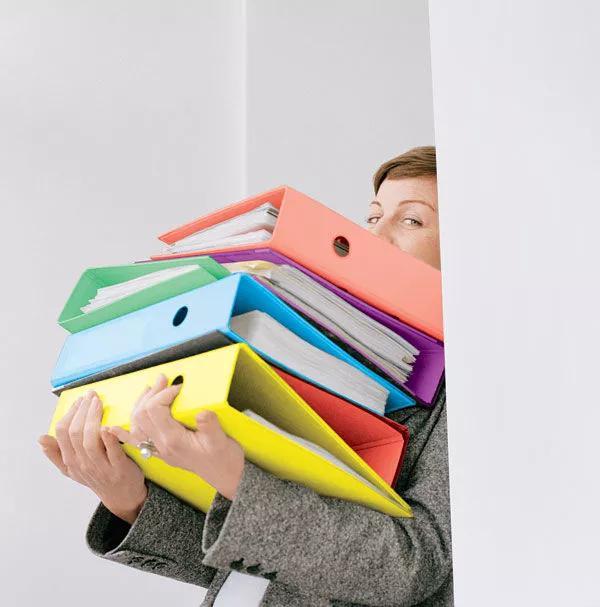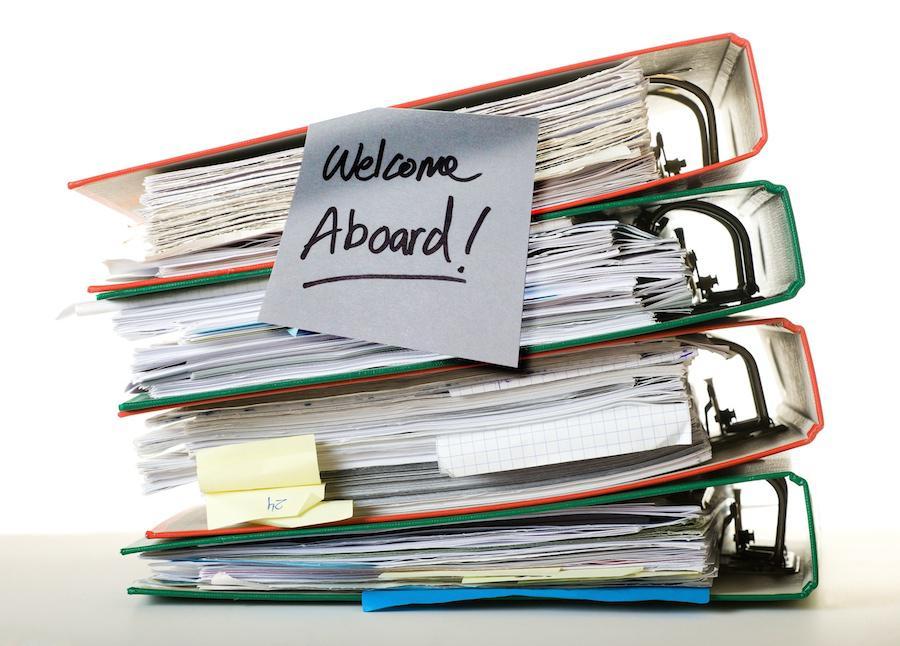The first image is the image on the left, the second image is the image on the right. Considering the images on both sides, is "A person's arms wrap around a bunch of binders in one image." valid? Answer yes or no. Yes. The first image is the image on the left, the second image is the image on the right. For the images displayed, is the sentence "A woman holds a pile of binders." factually correct? Answer yes or no. Yes. 